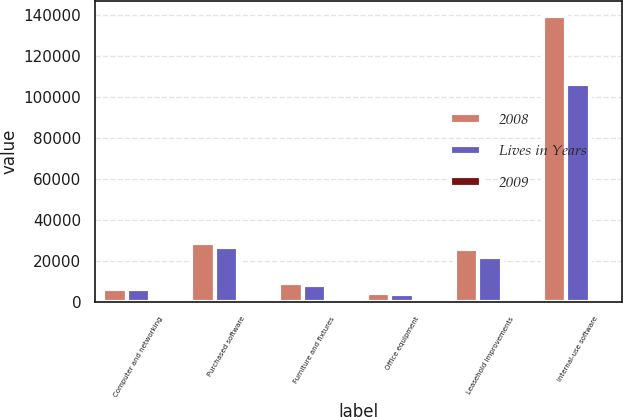Convert chart. <chart><loc_0><loc_0><loc_500><loc_500><stacked_bar_chart><ecel><fcel>Computer and networking<fcel>Purchased software<fcel>Furniture and fixtures<fcel>Office equipment<fcel>Leasehold improvements<fcel>Internal-use software<nl><fcel>2008<fcel>6382.5<fcel>28713<fcel>9491<fcel>4479<fcel>26026<fcel>139585<nl><fcel>Lives in Years<fcel>6382.5<fcel>26987<fcel>8286<fcel>3834<fcel>22095<fcel>106075<nl><fcel>2009<fcel>3<fcel>3<fcel>5<fcel>3<fcel>27<fcel>2<nl></chart> 